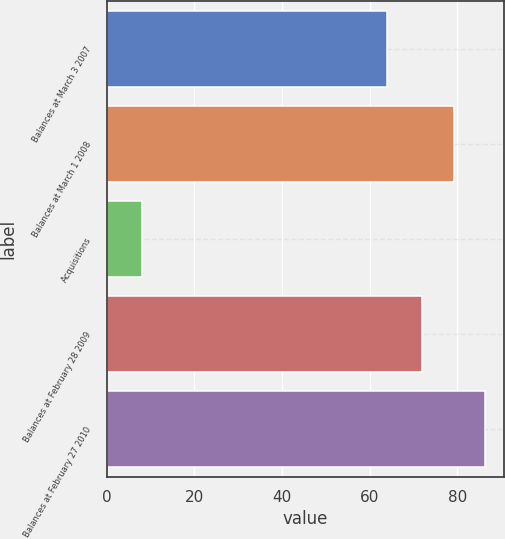Convert chart. <chart><loc_0><loc_0><loc_500><loc_500><bar_chart><fcel>Balances at March 3 2007<fcel>Balances at March 1 2008<fcel>Acquisitions<fcel>Balances at February 28 2009<fcel>Balances at February 27 2010<nl><fcel>64<fcel>79.2<fcel>8<fcel>72<fcel>86.4<nl></chart> 